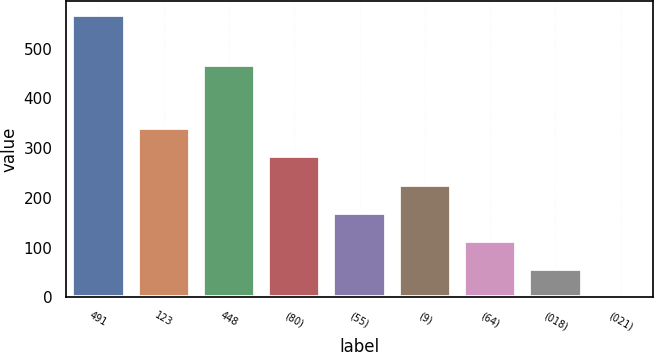Convert chart. <chart><loc_0><loc_0><loc_500><loc_500><bar_chart><fcel>491<fcel>123<fcel>448<fcel>(80)<fcel>(55)<fcel>(9)<fcel>(64)<fcel>(018)<fcel>(021)<nl><fcel>567<fcel>340.21<fcel>468<fcel>283.51<fcel>170.11<fcel>226.81<fcel>113.41<fcel>56.71<fcel>0.01<nl></chart> 